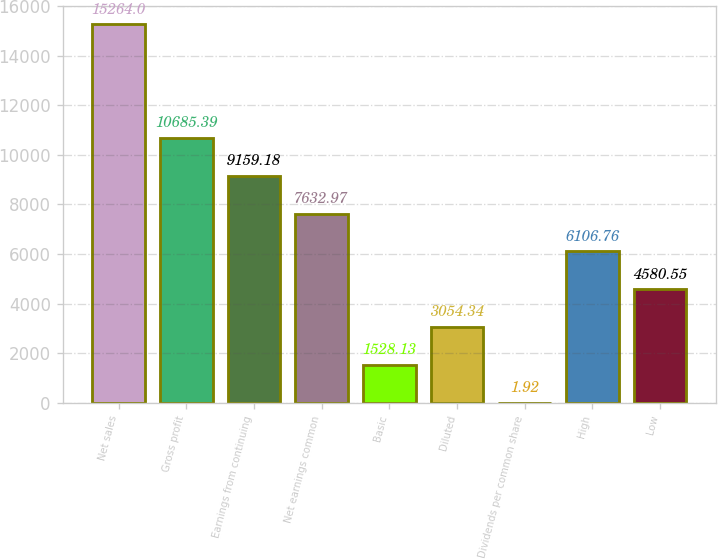Convert chart to OTSL. <chart><loc_0><loc_0><loc_500><loc_500><bar_chart><fcel>Net sales<fcel>Gross profit<fcel>Earnings from continuing<fcel>Net earnings common<fcel>Basic<fcel>Diluted<fcel>Dividends per common share<fcel>High<fcel>Low<nl><fcel>15264<fcel>10685.4<fcel>9159.18<fcel>7632.97<fcel>1528.13<fcel>3054.34<fcel>1.92<fcel>6106.76<fcel>4580.55<nl></chart> 